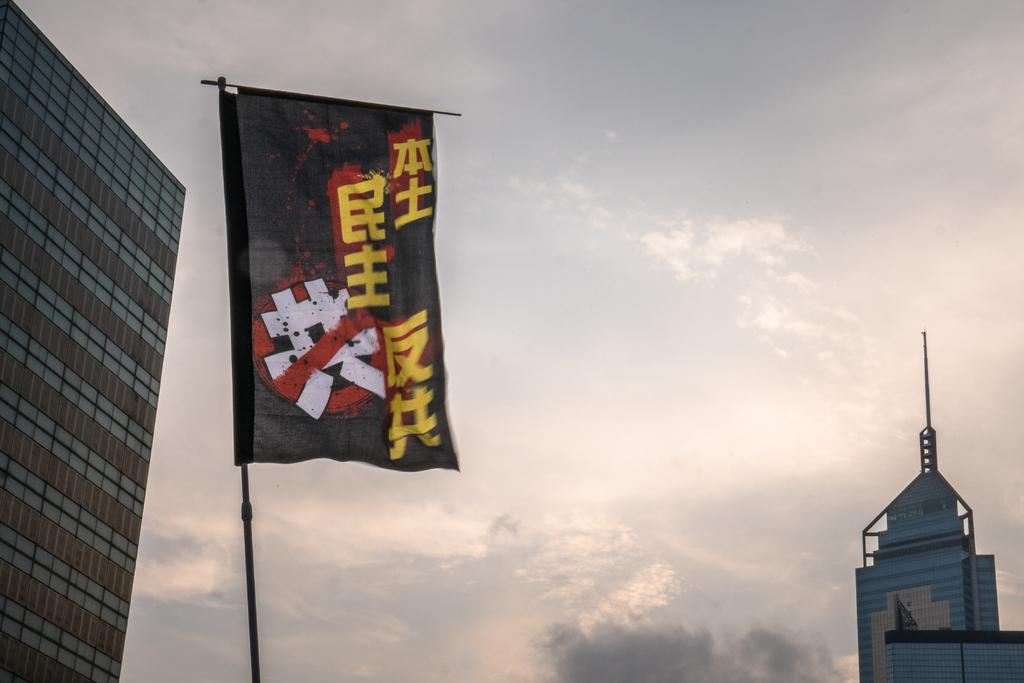What is attached to the pole in the image? There is a flag attached to the pole in the image. What can be seen on either side of the flag? There are buildings on both the left and right sides of the flag. What is visible behind the flag? The sky is visible behind the flag. What type of payment is being made in the image? There is no payment being made in the image; it features a flag on a pole with buildings and sky in the background. Is there a ship visible in the image? No, there is no ship present in the image. 